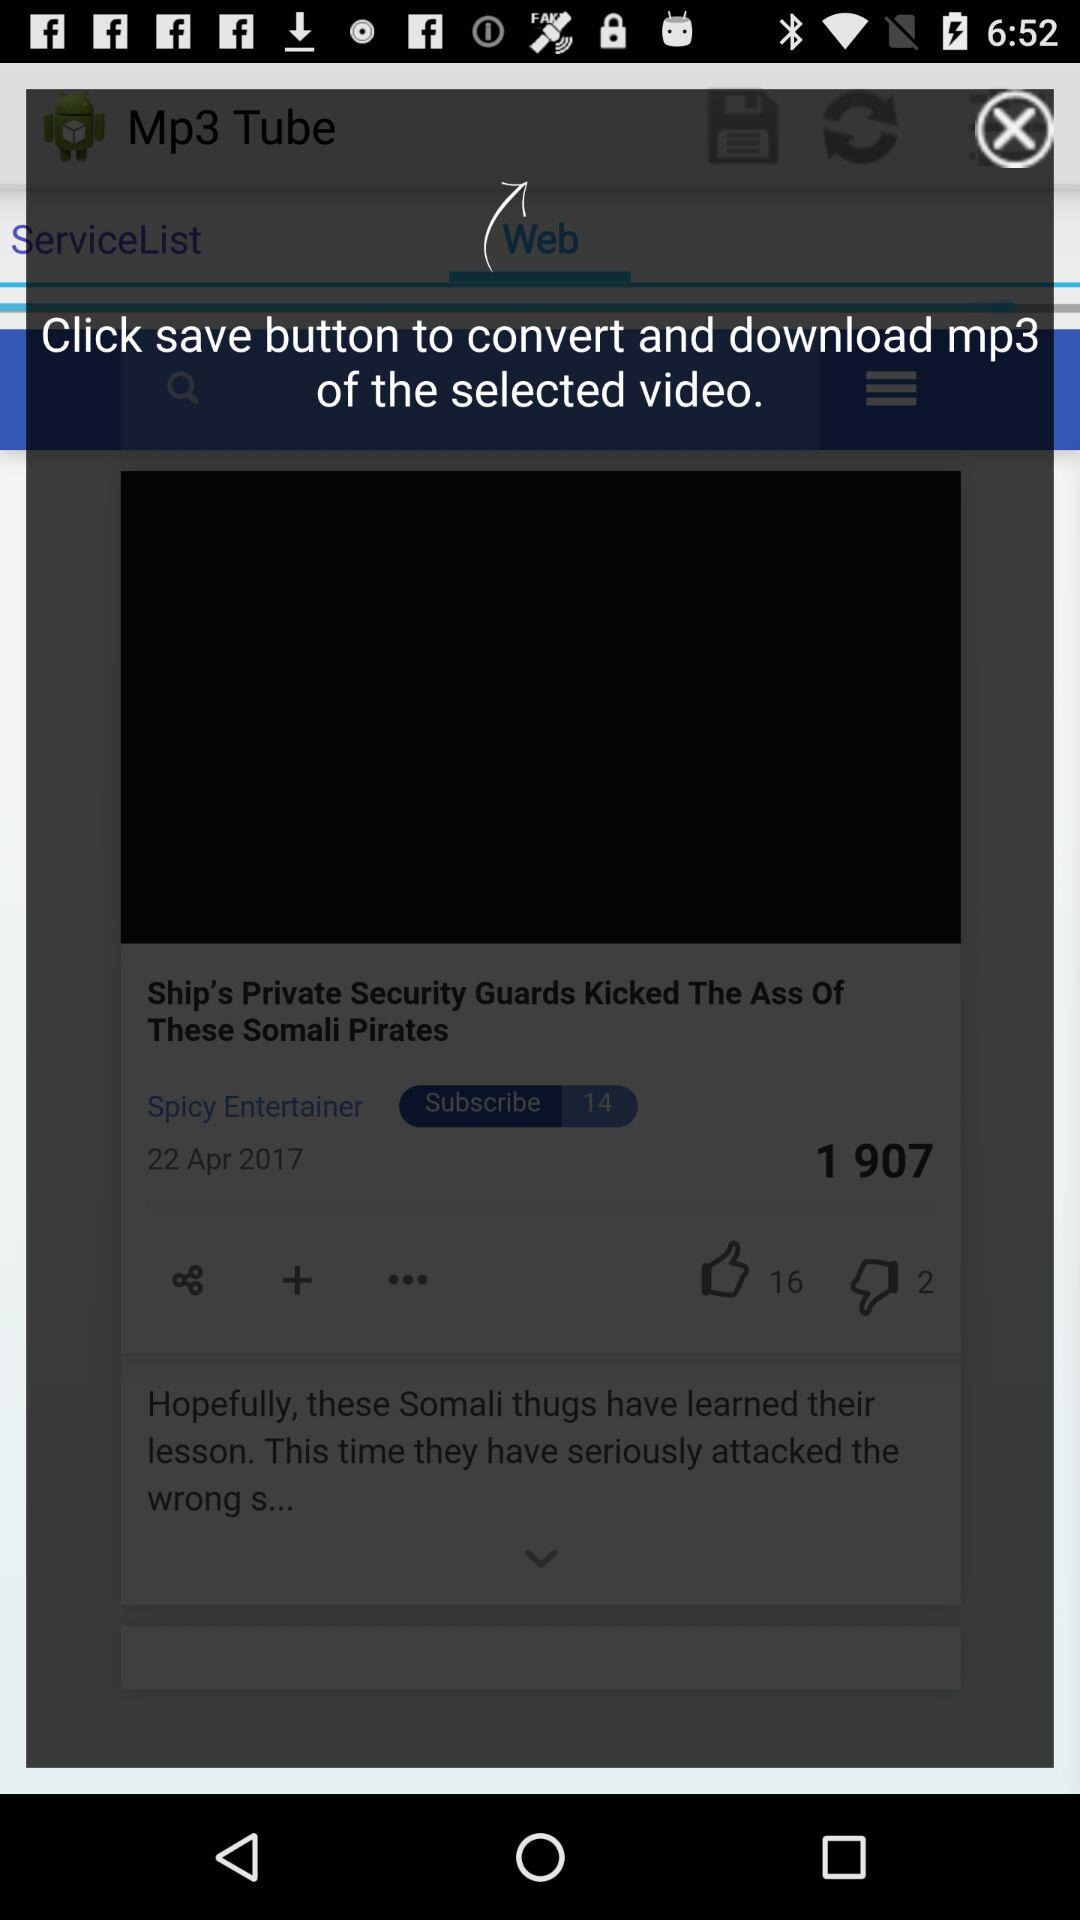How many more thumbs up than thumbs down are there on the video?
Answer the question using a single word or phrase. 14 